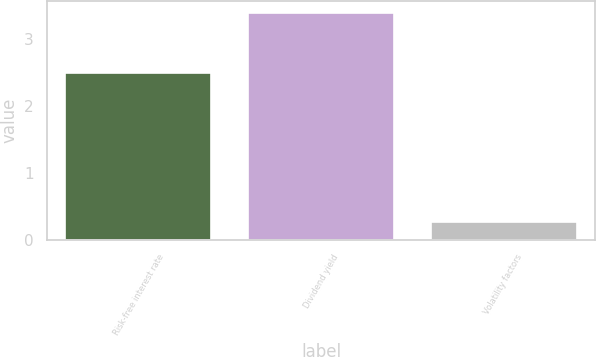Convert chart. <chart><loc_0><loc_0><loc_500><loc_500><bar_chart><fcel>Risk-free interest rate<fcel>Dividend yield<fcel>Volatility factors<nl><fcel>2.49<fcel>3.4<fcel>0.27<nl></chart> 